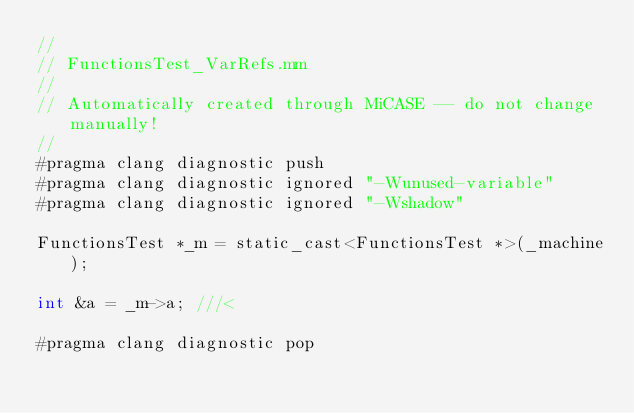Convert code to text. <code><loc_0><loc_0><loc_500><loc_500><_ObjectiveC_>//
// FunctionsTest_VarRefs.mm
//
// Automatically created through MiCASE -- do not change manually!
//
#pragma clang diagnostic push
#pragma clang diagnostic ignored "-Wunused-variable"
#pragma clang diagnostic ignored "-Wshadow"

FunctionsTest *_m = static_cast<FunctionsTest *>(_machine);

int	&a = _m->a;	///< 

#pragma clang diagnostic pop
</code> 